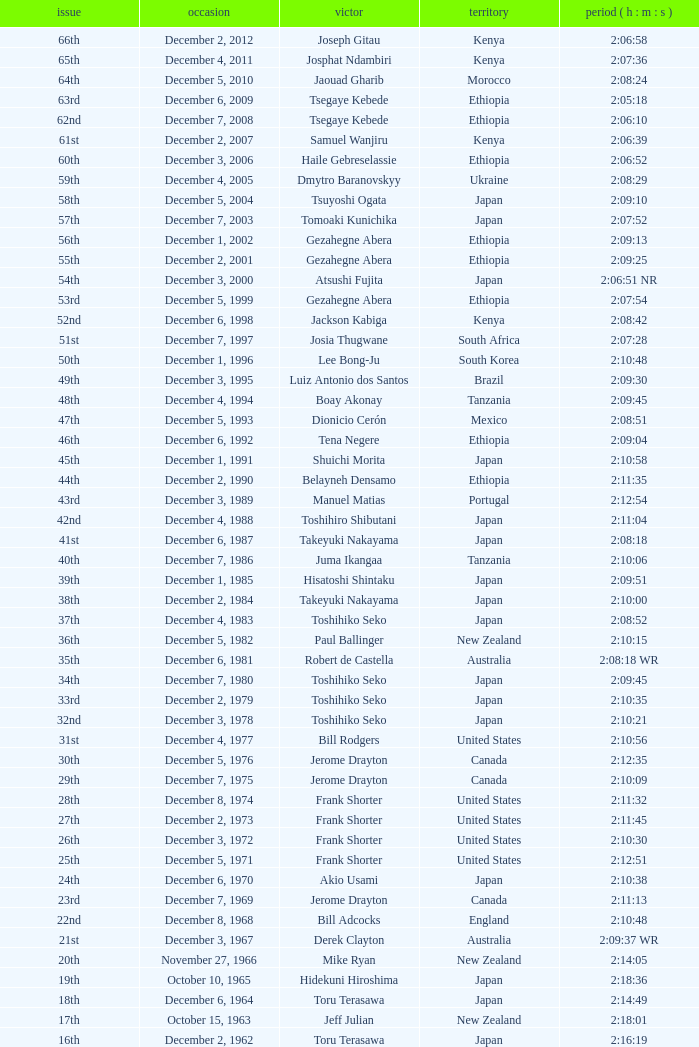What was the nationality of the winner on December 8, 1968? England. 